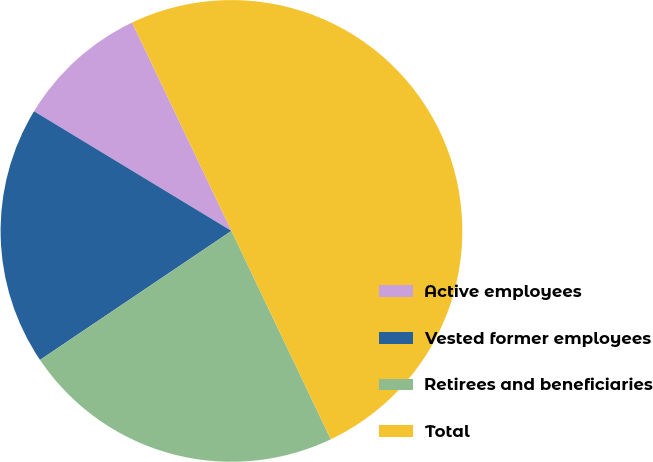Convert chart. <chart><loc_0><loc_0><loc_500><loc_500><pie_chart><fcel>Active employees<fcel>Vested former employees<fcel>Retirees and beneficiaries<fcel>Total<nl><fcel>9.25%<fcel>18.11%<fcel>22.64%<fcel>50.0%<nl></chart> 